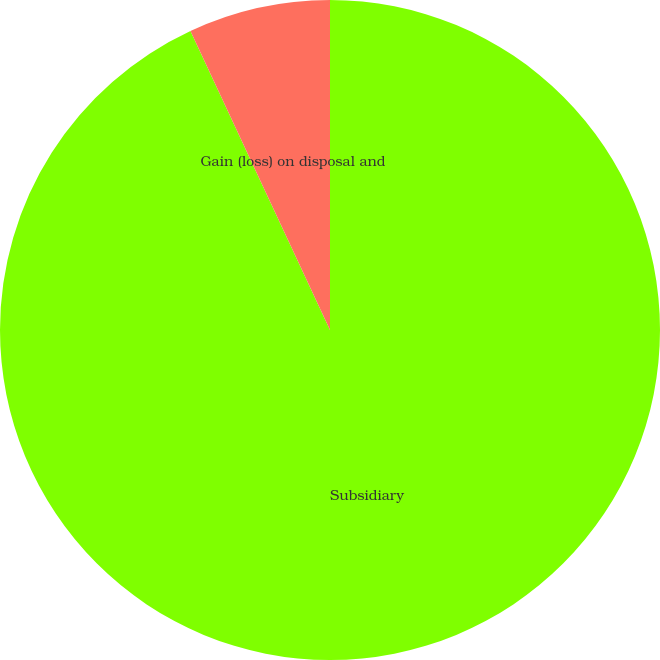Convert chart to OTSL. <chart><loc_0><loc_0><loc_500><loc_500><pie_chart><fcel>Subsidiary<fcel>Gain (loss) on disposal and<nl><fcel>93.05%<fcel>6.95%<nl></chart> 